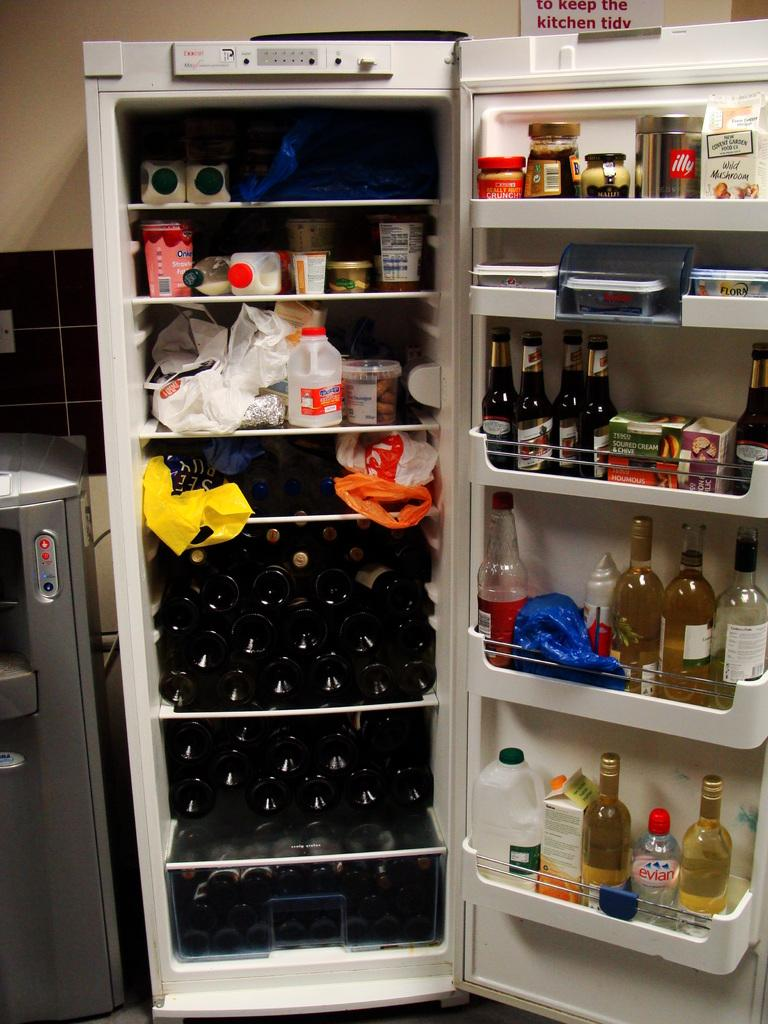<image>
Share a concise interpretation of the image provided. A sign telling people to keep the kitchen tidy hangs near the refrigerator. 